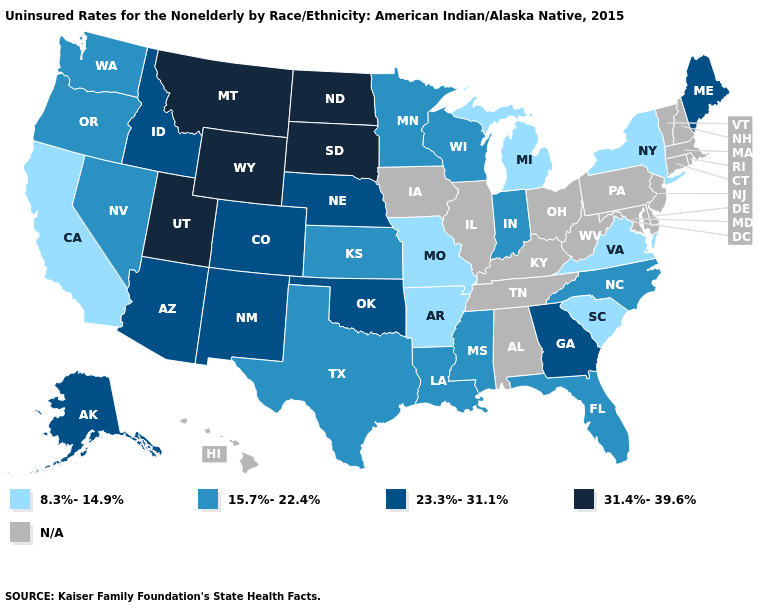Name the states that have a value in the range N/A?
Write a very short answer. Alabama, Connecticut, Delaware, Hawaii, Illinois, Iowa, Kentucky, Maryland, Massachusetts, New Hampshire, New Jersey, Ohio, Pennsylvania, Rhode Island, Tennessee, Vermont, West Virginia. What is the highest value in states that border Florida?
Concise answer only. 23.3%-31.1%. What is the highest value in the West ?
Answer briefly. 31.4%-39.6%. Name the states that have a value in the range 15.7%-22.4%?
Short answer required. Florida, Indiana, Kansas, Louisiana, Minnesota, Mississippi, Nevada, North Carolina, Oregon, Texas, Washington, Wisconsin. Which states hav the highest value in the MidWest?
Be succinct. North Dakota, South Dakota. What is the value of Iowa?
Give a very brief answer. N/A. Which states hav the highest value in the West?
Write a very short answer. Montana, Utah, Wyoming. Does the map have missing data?
Give a very brief answer. Yes. How many symbols are there in the legend?
Answer briefly. 5. Which states have the highest value in the USA?
Be succinct. Montana, North Dakota, South Dakota, Utah, Wyoming. What is the value of Alabama?
Give a very brief answer. N/A. What is the highest value in the USA?
Be succinct. 31.4%-39.6%. What is the highest value in the USA?
Keep it brief. 31.4%-39.6%. Name the states that have a value in the range 31.4%-39.6%?
Quick response, please. Montana, North Dakota, South Dakota, Utah, Wyoming. What is the value of Florida?
Keep it brief. 15.7%-22.4%. 